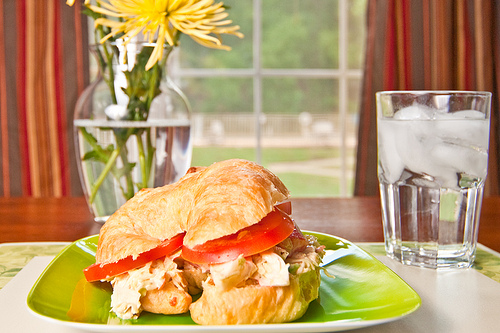Are the flowers yellow or purple? The flowers are a vibrant yellow color. 